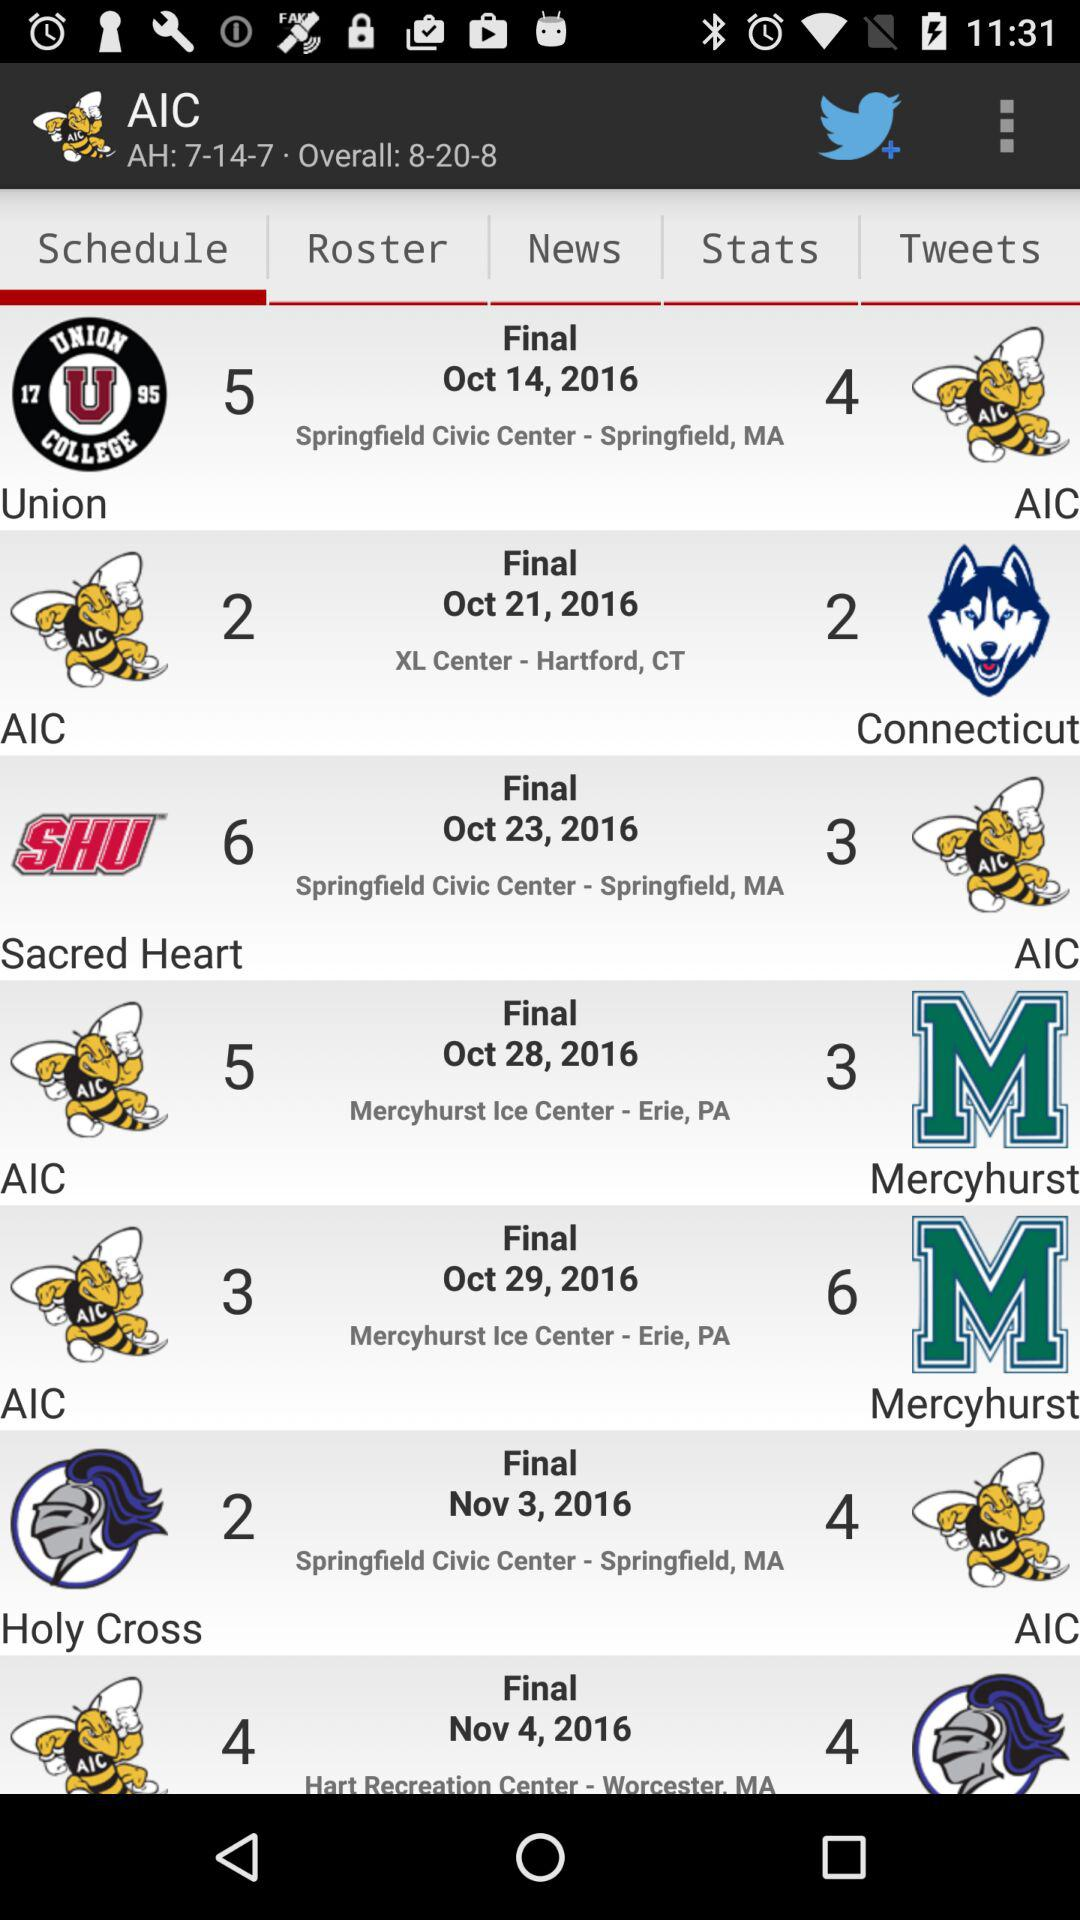Which tab has been selected?
Answer the question using a single word or phrase. The tab that has been selected is "Schedule" 